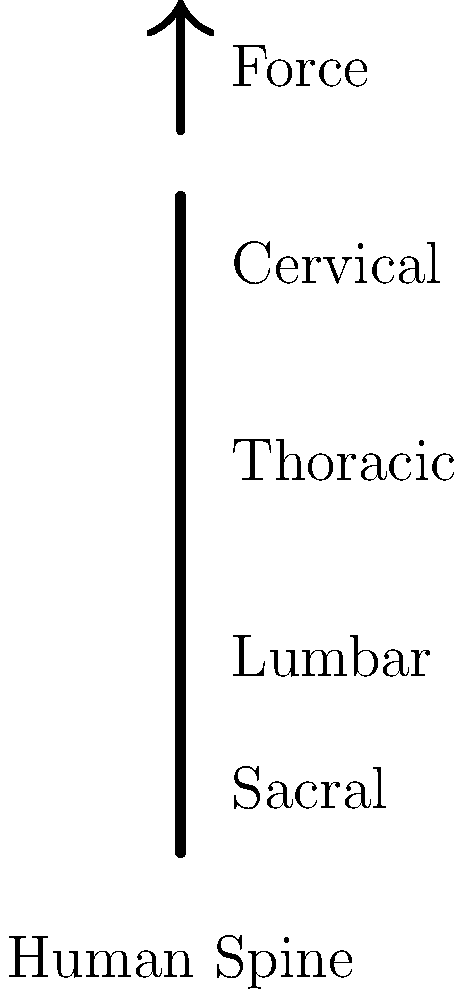A dictator stands at a podium for extended periods during speeches. Given that the average human head weighs approximately 5 kg and the distance from the base of the skull to the lumbar region is about 40 cm, calculate the moment (torque) experienced by the lumbar spine. Assume the center of mass of the head is 15 cm from the base of the skull, and gravity is 9.8 m/s². Use the labeled diagram for reference. To calculate the moment (torque) experienced by the lumbar spine, we need to follow these steps:

1. Identify the relevant information:
   - Mass of the head (m) = 5 kg
   - Distance from base of skull to lumbar region (d₁) = 40 cm = 0.4 m
   - Distance from base of skull to center of mass of head (d₂) = 15 cm = 0.15 m
   - Acceleration due to gravity (g) = 9.8 m/s²

2. Calculate the force exerted by the head:
   F = m × g
   F = 5 kg × 9.8 m/s² = 49 N

3. Calculate the moment arm:
   Moment arm = d₁ - d₂ = 0.4 m - 0.15 m = 0.25 m

4. Calculate the moment (torque):
   Moment = Force × Moment arm
   Moment = 49 N × 0.25 m = 12.25 N·m

Therefore, the moment (torque) experienced by the lumbar spine is 12.25 N·m.
Answer: 12.25 N·m 